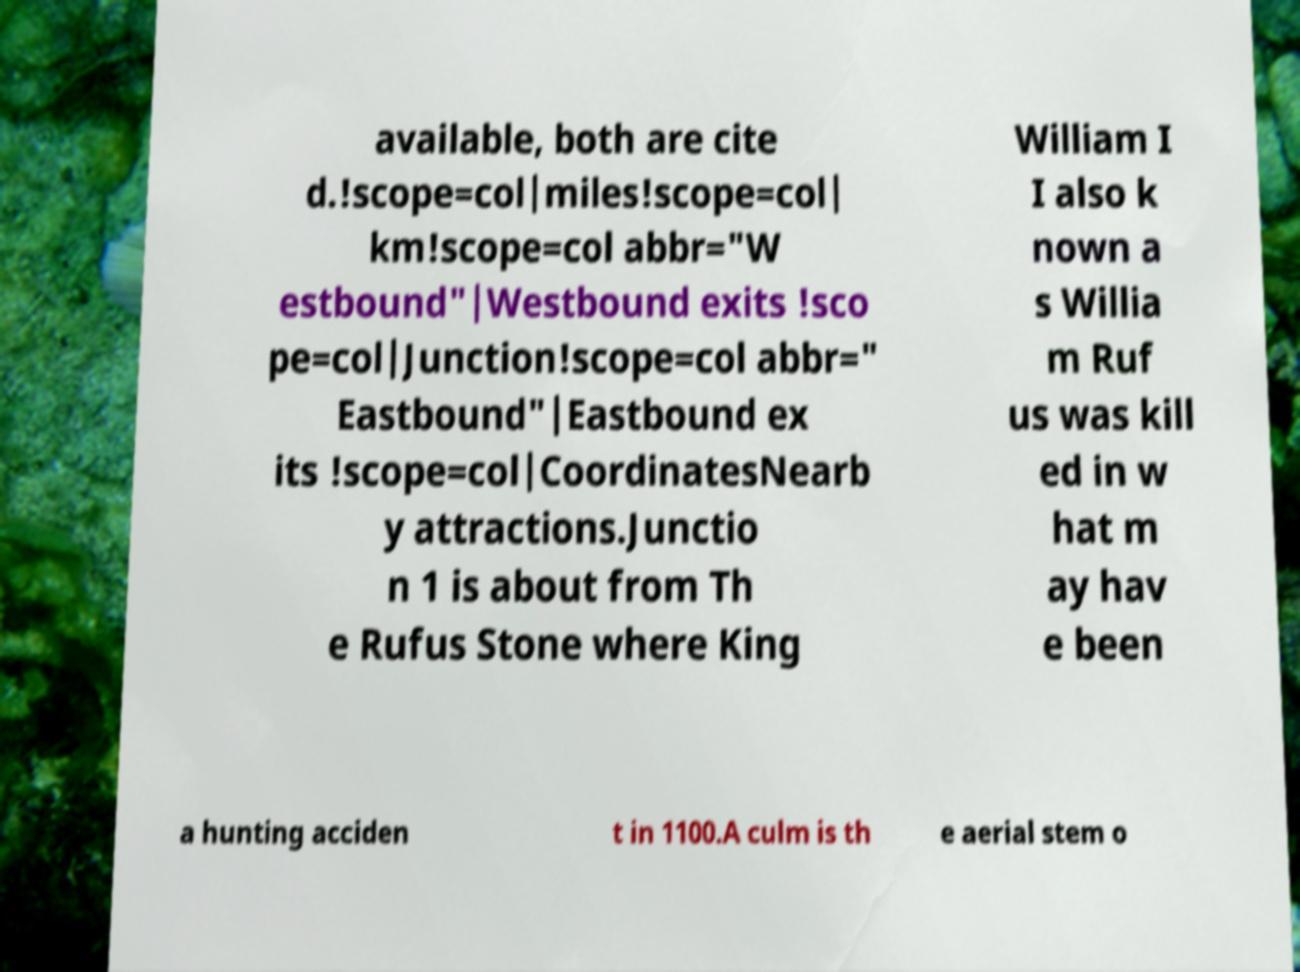Could you extract and type out the text from this image? available, both are cite d.!scope=col|miles!scope=col| km!scope=col abbr="W estbound"|Westbound exits !sco pe=col|Junction!scope=col abbr=" Eastbound"|Eastbound ex its !scope=col|CoordinatesNearb y attractions.Junctio n 1 is about from Th e Rufus Stone where King William I I also k nown a s Willia m Ruf us was kill ed in w hat m ay hav e been a hunting acciden t in 1100.A culm is th e aerial stem o 